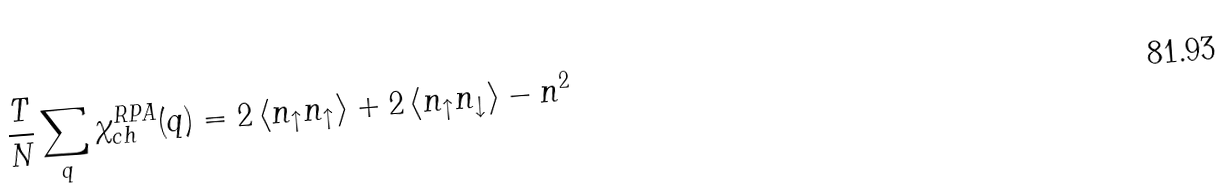Convert formula to latex. <formula><loc_0><loc_0><loc_500><loc_500>\frac { T } { N } \sum _ { q } \chi _ { c h } ^ { R P A } ( q ) = 2 \left \langle n _ { \uparrow } n _ { \uparrow } \right \rangle + 2 \left \langle n _ { \uparrow } n _ { \downarrow } \right \rangle - n ^ { 2 }</formula> 